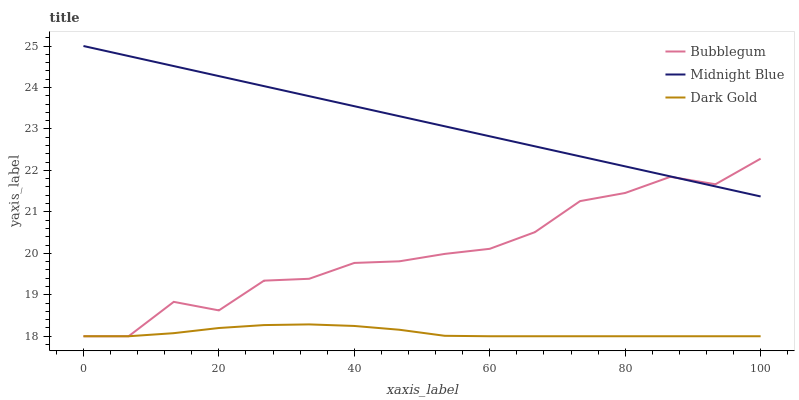Does Bubblegum have the minimum area under the curve?
Answer yes or no. No. Does Bubblegum have the maximum area under the curve?
Answer yes or no. No. Is Dark Gold the smoothest?
Answer yes or no. No. Is Dark Gold the roughest?
Answer yes or no. No. Does Bubblegum have the highest value?
Answer yes or no. No. Is Dark Gold less than Midnight Blue?
Answer yes or no. Yes. Is Midnight Blue greater than Dark Gold?
Answer yes or no. Yes. Does Dark Gold intersect Midnight Blue?
Answer yes or no. No. 